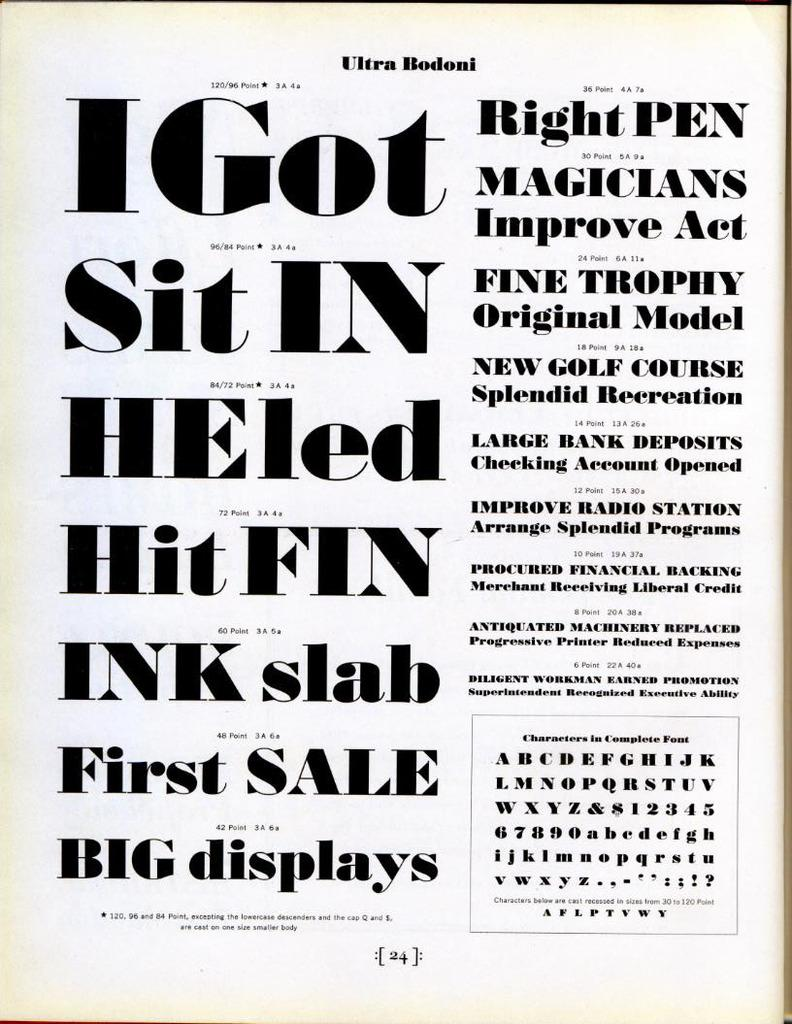<image>
Give a short and clear explanation of the subsequent image. the front page for a book called right pen magicians improve act. 